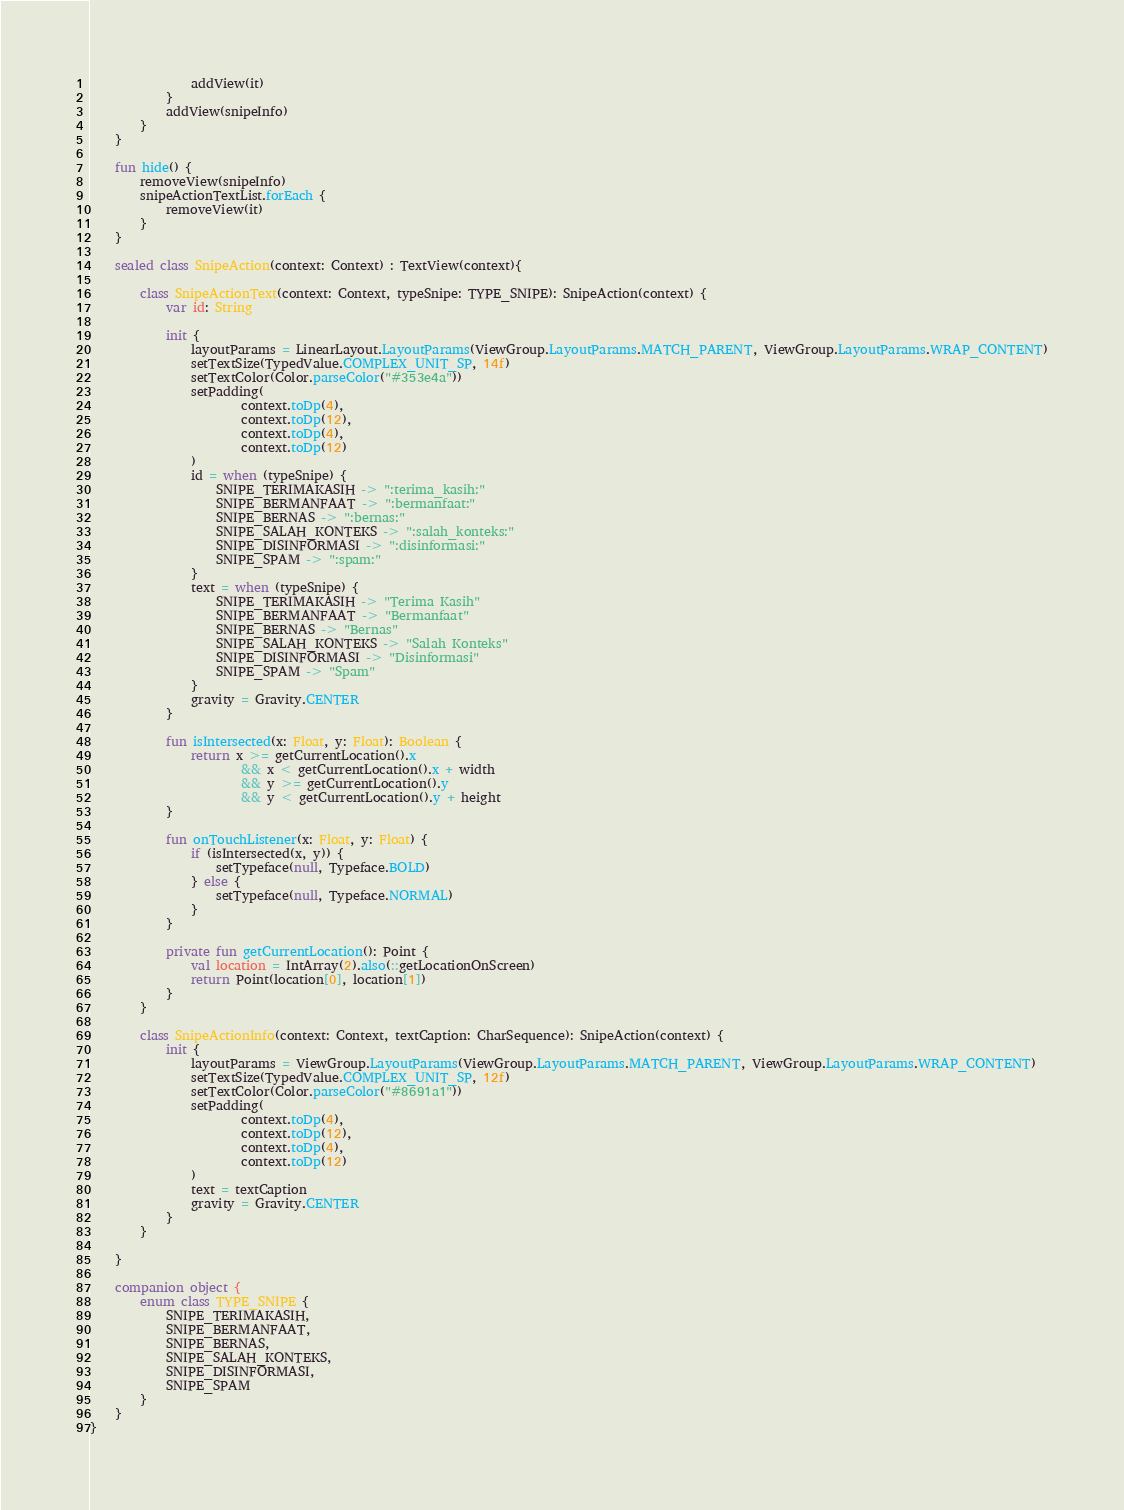<code> <loc_0><loc_0><loc_500><loc_500><_Kotlin_>                addView(it)
            }
            addView(snipeInfo)
        }
    }

    fun hide() {
        removeView(snipeInfo)
        snipeActionTextList.forEach {
            removeView(it)
        }
    }

    sealed class SnipeAction(context: Context) : TextView(context){

        class SnipeActionText(context: Context, typeSnipe: TYPE_SNIPE): SnipeAction(context) {
            var id: String

            init {
                layoutParams = LinearLayout.LayoutParams(ViewGroup.LayoutParams.MATCH_PARENT, ViewGroup.LayoutParams.WRAP_CONTENT)
                setTextSize(TypedValue.COMPLEX_UNIT_SP, 14f)
                setTextColor(Color.parseColor("#353e4a"))
                setPadding(
                        context.toDp(4),
                        context.toDp(12),
                        context.toDp(4),
                        context.toDp(12)
                )
                id = when (typeSnipe) {
                    SNIPE_TERIMAKASIH -> ":terima_kasih:"
                    SNIPE_BERMANFAAT -> ":bermanfaat:"
                    SNIPE_BERNAS -> ":bernas:"
                    SNIPE_SALAH_KONTEKS -> ":salah_konteks:"
                    SNIPE_DISINFORMASI -> ":disinformasi:"
                    SNIPE_SPAM -> ":spam:"
                }
                text = when (typeSnipe) {
                    SNIPE_TERIMAKASIH -> "Terima Kasih"
                    SNIPE_BERMANFAAT -> "Bermanfaat"
                    SNIPE_BERNAS -> "Bernas"
                    SNIPE_SALAH_KONTEKS -> "Salah Konteks"
                    SNIPE_DISINFORMASI -> "Disinformasi"
                    SNIPE_SPAM -> "Spam"
                }
                gravity = Gravity.CENTER
            }

            fun isIntersected(x: Float, y: Float): Boolean {
                return x >= getCurrentLocation().x
                        && x < getCurrentLocation().x + width
                        && y >= getCurrentLocation().y
                        && y < getCurrentLocation().y + height
            }

            fun onTouchListener(x: Float, y: Float) {
                if (isIntersected(x, y)) {
                    setTypeface(null, Typeface.BOLD)
                } else {
                    setTypeface(null, Typeface.NORMAL)
                }
            }

            private fun getCurrentLocation(): Point {
                val location = IntArray(2).also(::getLocationOnScreen)
                return Point(location[0], location[1])
            }
        }

        class SnipeActionInfo(context: Context, textCaption: CharSequence): SnipeAction(context) {
            init {
                layoutParams = ViewGroup.LayoutParams(ViewGroup.LayoutParams.MATCH_PARENT, ViewGroup.LayoutParams.WRAP_CONTENT)
                setTextSize(TypedValue.COMPLEX_UNIT_SP, 12f)
                setTextColor(Color.parseColor("#8691a1"))
                setPadding(
                        context.toDp(4),
                        context.toDp(12),
                        context.toDp(4),
                        context.toDp(12)
                )
                text = textCaption
                gravity = Gravity.CENTER
            }
        }

    }

    companion object {
        enum class TYPE_SNIPE {
            SNIPE_TERIMAKASIH,
            SNIPE_BERMANFAAT,
            SNIPE_BERNAS,
            SNIPE_SALAH_KONTEKS,
            SNIPE_DISINFORMASI,
            SNIPE_SPAM
        }
    }
}</code> 